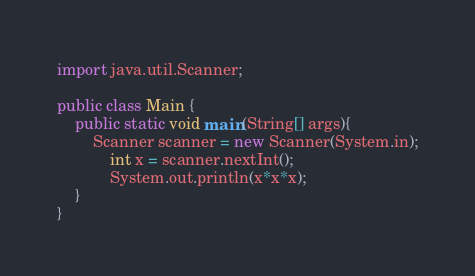Convert code to text. <code><loc_0><loc_0><loc_500><loc_500><_Java_>import java.util.Scanner;

public class Main { 
    public static void main(String[] args){
        Scanner scanner = new Scanner(System.in);
            int x = scanner.nextInt();
            System.out.println(x*x*x);
    }
}
</code> 